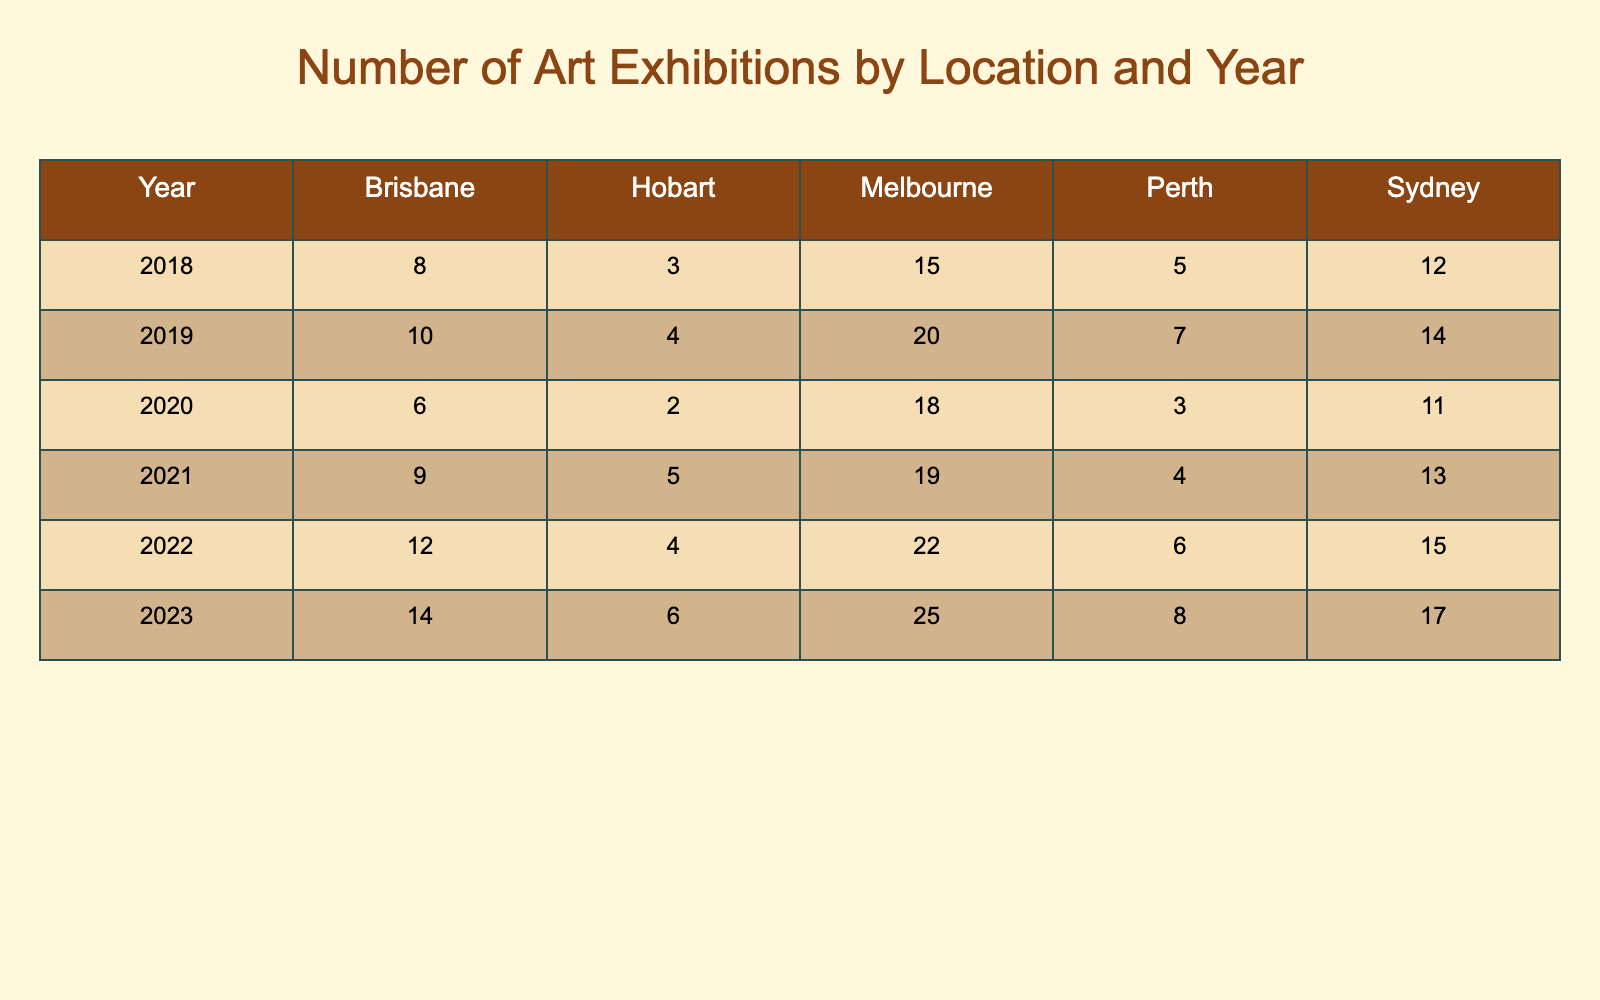What was the total number of art exhibitions held in Sydney from 2018 to 2023? The values for Sydney from the years 2018 to 2023 are: 12 (2018), 14 (2019), 11 (2020), 13 (2021), 15 (2022), 17 (2023). Adding these gives us 12 + 14 + 11 + 13 + 15 + 17 = 82.
Answer: 82 Which location had the highest number of art exhibitions in 2022? In 2022, the number of art exhibitions by location were: Sydney (15), Melbourne (22), Brisbane (12), Perth (6), Hobart (4). The highest value is 22, corresponding to Melbourne.
Answer: Melbourne Did the number of exhibitions in Brisbane increase from 2018 to 2023? The numbers of exhibitions in Brisbane from 2018 to 2023 are: 8 (2018), 10 (2019), 6 (2020), 9 (2021), 12 (2022), 14 (2023). There is an increase noted from 2018 to 2023, as 8 < 14.
Answer: Yes What is the average number of art exhibitions held in Melbourne over the years? The values for Melbourne from 2018 to 2023 are: 15 (2018), 20 (2019), 18 (2020), 19 (2021), 22 (2022), 25 (2023). The sum is 15 + 20 + 18 + 19 + 22 + 25 = 119. There are 6 data points which gives an average of 119/6 = 19.83.
Answer: 19.83 In which year did Perth have the least number of art exhibitions? The values for Perth each year are: 5 (2018), 7 (2019), 3 (2020), 4 (2021), 6 (2022), 8 (2023). The lowest value is 3, which occurs in 2020.
Answer: 2020 Was there a decrease in the total number of art exhibitions held in Hobart from 2018 to 2020? The values for Hobart are: 3 (2018), 4 (2019), 2 (2020). The total in 2018 and 2019 is 3 + 4 = 7, while in 2020 it is 2. Since 7 > 2, there was a decrease in exhibitions in Hobart.
Answer: Yes Which year showed the highest cumulative number of exhibitions across all locations? To find this, we calculate the total exhibitions for each year. For 2018: 12+15+8+5+3=43; for 2019: 14+20+10+7+4=65; for 2020: 11+18+6+3+2=40; for 2021: 13+19+9+4+5=50; for 2022: 15+22+12+6+4=59; for 2023: 17+25+14+8+6=70. The highest cumulative total is for 2019 with 65 exhibitions.
Answer: 2019 What was the increase in the number of exhibitions in Sydney from 2020 to 2022? The number of exhibitions in Sydney was 11 in 2020 and 15 in 2022. The increase is calculated as 15 - 11 = 4.
Answer: 4 